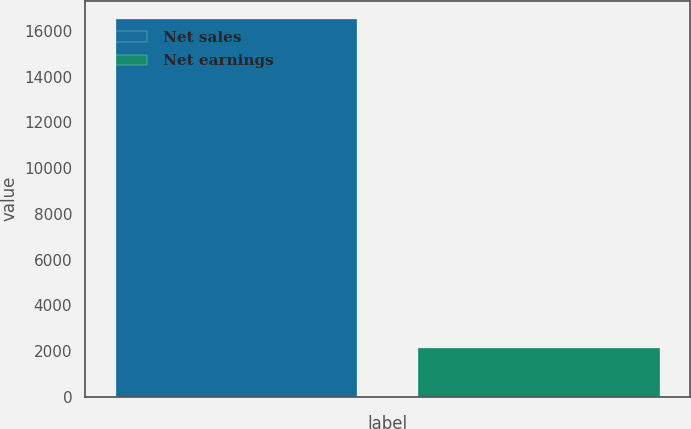Convert chart to OTSL. <chart><loc_0><loc_0><loc_500><loc_500><bar_chart><fcel>Net sales<fcel>Net earnings<nl><fcel>16493<fcel>2123<nl></chart> 